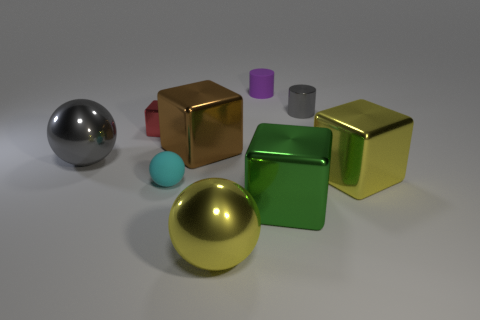What is the tiny thing in front of the yellow cube to the right of the large metallic sphere that is on the right side of the gray sphere made of?
Keep it short and to the point. Rubber. Is the tiny cyan thing the same shape as the red metal thing?
Offer a very short reply. No. There is a big yellow thing that is the same shape as the red object; what is it made of?
Offer a very short reply. Metal. What number of big spheres have the same color as the tiny metallic cylinder?
Make the answer very short. 1. There is a brown object that is the same material as the yellow sphere; what is its size?
Your response must be concise. Large. What number of purple objects are either blocks or big metallic balls?
Provide a short and direct response. 0. There is a small thing that is in front of the brown object; how many metallic things are to the left of it?
Offer a terse response. 2. Is the number of red metallic things left of the cyan rubber thing greater than the number of matte cylinders that are in front of the yellow sphere?
Your answer should be very brief. Yes. What is the material of the small cyan sphere?
Provide a succinct answer. Rubber. Are there any red shiny things that have the same size as the red block?
Give a very brief answer. No. 